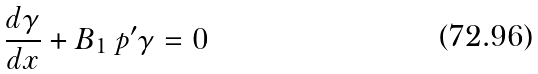<formula> <loc_0><loc_0><loc_500><loc_500>\frac { d \gamma } { d x } + B _ { 1 } \ p ^ { \prime } \gamma = 0</formula> 